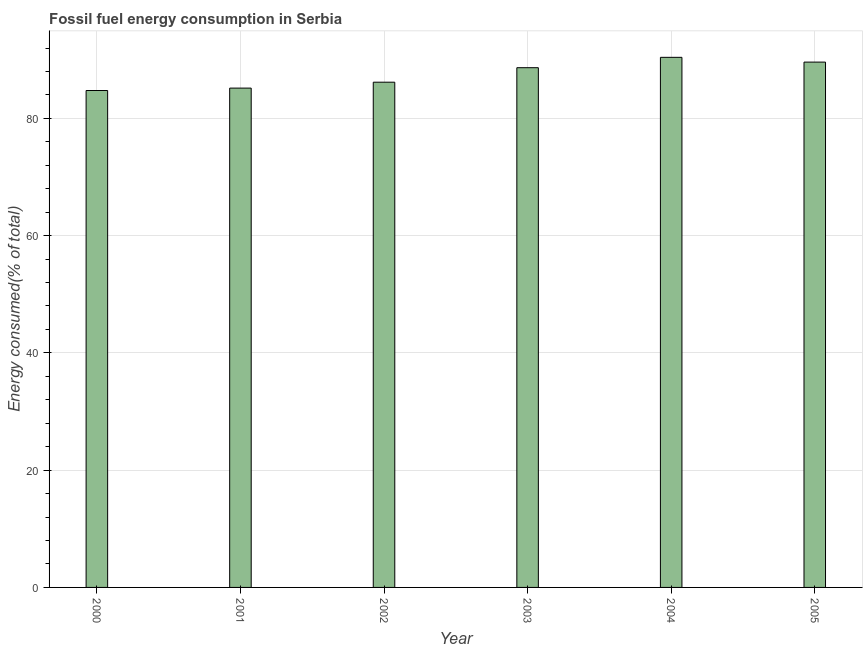Does the graph contain any zero values?
Offer a very short reply. No. Does the graph contain grids?
Make the answer very short. Yes. What is the title of the graph?
Give a very brief answer. Fossil fuel energy consumption in Serbia. What is the label or title of the X-axis?
Offer a terse response. Year. What is the label or title of the Y-axis?
Your answer should be compact. Energy consumed(% of total). What is the fossil fuel energy consumption in 2001?
Offer a very short reply. 85.16. Across all years, what is the maximum fossil fuel energy consumption?
Provide a succinct answer. 90.41. Across all years, what is the minimum fossil fuel energy consumption?
Your answer should be very brief. 84.75. In which year was the fossil fuel energy consumption maximum?
Your response must be concise. 2004. In which year was the fossil fuel energy consumption minimum?
Offer a very short reply. 2000. What is the sum of the fossil fuel energy consumption?
Provide a succinct answer. 524.73. What is the difference between the fossil fuel energy consumption in 2000 and 2004?
Your response must be concise. -5.66. What is the average fossil fuel energy consumption per year?
Make the answer very short. 87.45. What is the median fossil fuel energy consumption?
Give a very brief answer. 87.4. What is the ratio of the fossil fuel energy consumption in 2001 to that in 2003?
Offer a terse response. 0.96. Is the fossil fuel energy consumption in 2001 less than that in 2003?
Offer a terse response. Yes. What is the difference between the highest and the second highest fossil fuel energy consumption?
Make the answer very short. 0.81. What is the difference between the highest and the lowest fossil fuel energy consumption?
Your answer should be compact. 5.66. In how many years, is the fossil fuel energy consumption greater than the average fossil fuel energy consumption taken over all years?
Give a very brief answer. 3. Are all the bars in the graph horizontal?
Offer a very short reply. No. How many years are there in the graph?
Ensure brevity in your answer.  6. What is the difference between two consecutive major ticks on the Y-axis?
Your answer should be very brief. 20. What is the Energy consumed(% of total) of 2000?
Your answer should be compact. 84.75. What is the Energy consumed(% of total) in 2001?
Provide a succinct answer. 85.16. What is the Energy consumed(% of total) of 2002?
Provide a succinct answer. 86.17. What is the Energy consumed(% of total) of 2003?
Your answer should be compact. 88.64. What is the Energy consumed(% of total) in 2004?
Your response must be concise. 90.41. What is the Energy consumed(% of total) of 2005?
Your response must be concise. 89.6. What is the difference between the Energy consumed(% of total) in 2000 and 2001?
Make the answer very short. -0.41. What is the difference between the Energy consumed(% of total) in 2000 and 2002?
Your answer should be very brief. -1.42. What is the difference between the Energy consumed(% of total) in 2000 and 2003?
Your answer should be compact. -3.89. What is the difference between the Energy consumed(% of total) in 2000 and 2004?
Ensure brevity in your answer.  -5.66. What is the difference between the Energy consumed(% of total) in 2000 and 2005?
Your answer should be compact. -4.84. What is the difference between the Energy consumed(% of total) in 2001 and 2002?
Your answer should be compact. -1.01. What is the difference between the Energy consumed(% of total) in 2001 and 2003?
Your answer should be compact. -3.48. What is the difference between the Energy consumed(% of total) in 2001 and 2004?
Your response must be concise. -5.25. What is the difference between the Energy consumed(% of total) in 2001 and 2005?
Provide a succinct answer. -4.43. What is the difference between the Energy consumed(% of total) in 2002 and 2003?
Give a very brief answer. -2.47. What is the difference between the Energy consumed(% of total) in 2002 and 2004?
Give a very brief answer. -4.24. What is the difference between the Energy consumed(% of total) in 2002 and 2005?
Give a very brief answer. -3.43. What is the difference between the Energy consumed(% of total) in 2003 and 2004?
Keep it short and to the point. -1.77. What is the difference between the Energy consumed(% of total) in 2003 and 2005?
Offer a very short reply. -0.95. What is the difference between the Energy consumed(% of total) in 2004 and 2005?
Make the answer very short. 0.81. What is the ratio of the Energy consumed(% of total) in 2000 to that in 2001?
Offer a very short reply. 0.99. What is the ratio of the Energy consumed(% of total) in 2000 to that in 2003?
Offer a terse response. 0.96. What is the ratio of the Energy consumed(% of total) in 2000 to that in 2004?
Keep it short and to the point. 0.94. What is the ratio of the Energy consumed(% of total) in 2000 to that in 2005?
Offer a very short reply. 0.95. What is the ratio of the Energy consumed(% of total) in 2001 to that in 2003?
Offer a very short reply. 0.96. What is the ratio of the Energy consumed(% of total) in 2001 to that in 2004?
Your answer should be very brief. 0.94. What is the ratio of the Energy consumed(% of total) in 2001 to that in 2005?
Make the answer very short. 0.95. What is the ratio of the Energy consumed(% of total) in 2002 to that in 2004?
Keep it short and to the point. 0.95. What is the ratio of the Energy consumed(% of total) in 2003 to that in 2005?
Your response must be concise. 0.99. What is the ratio of the Energy consumed(% of total) in 2004 to that in 2005?
Offer a terse response. 1.01. 